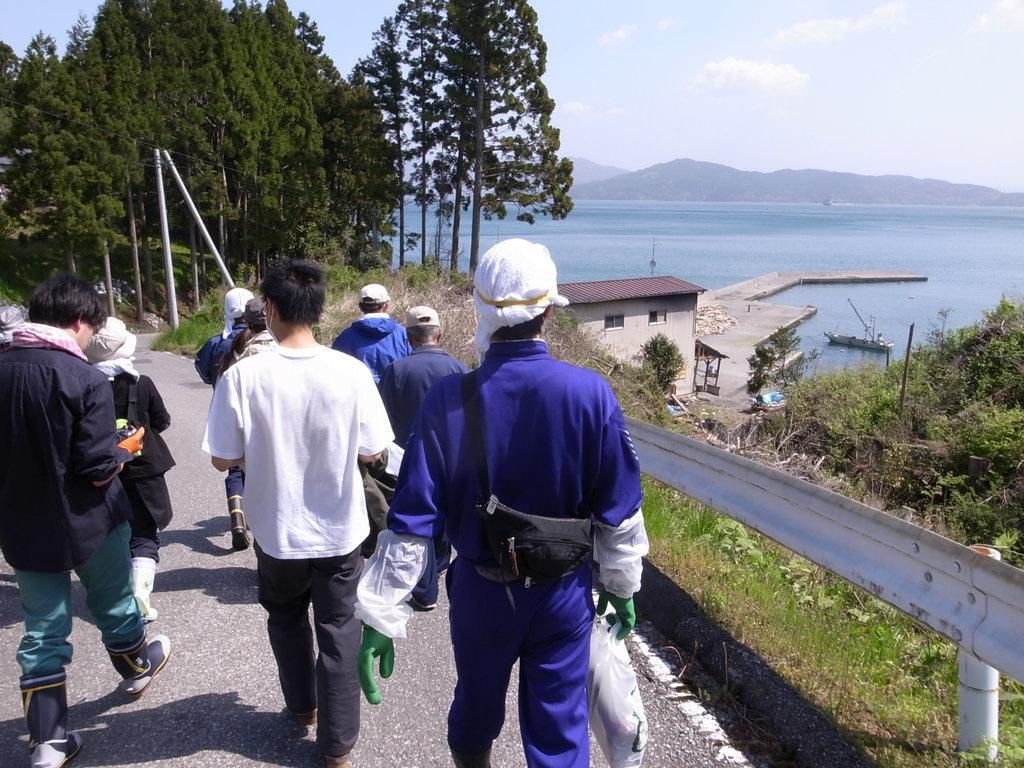Could you give a brief overview of what you see in this image? In this image we can see people walking on the road, walkway bridge, building, ship, poles, plants, grass, river, hills, trees and sky with clouds. 